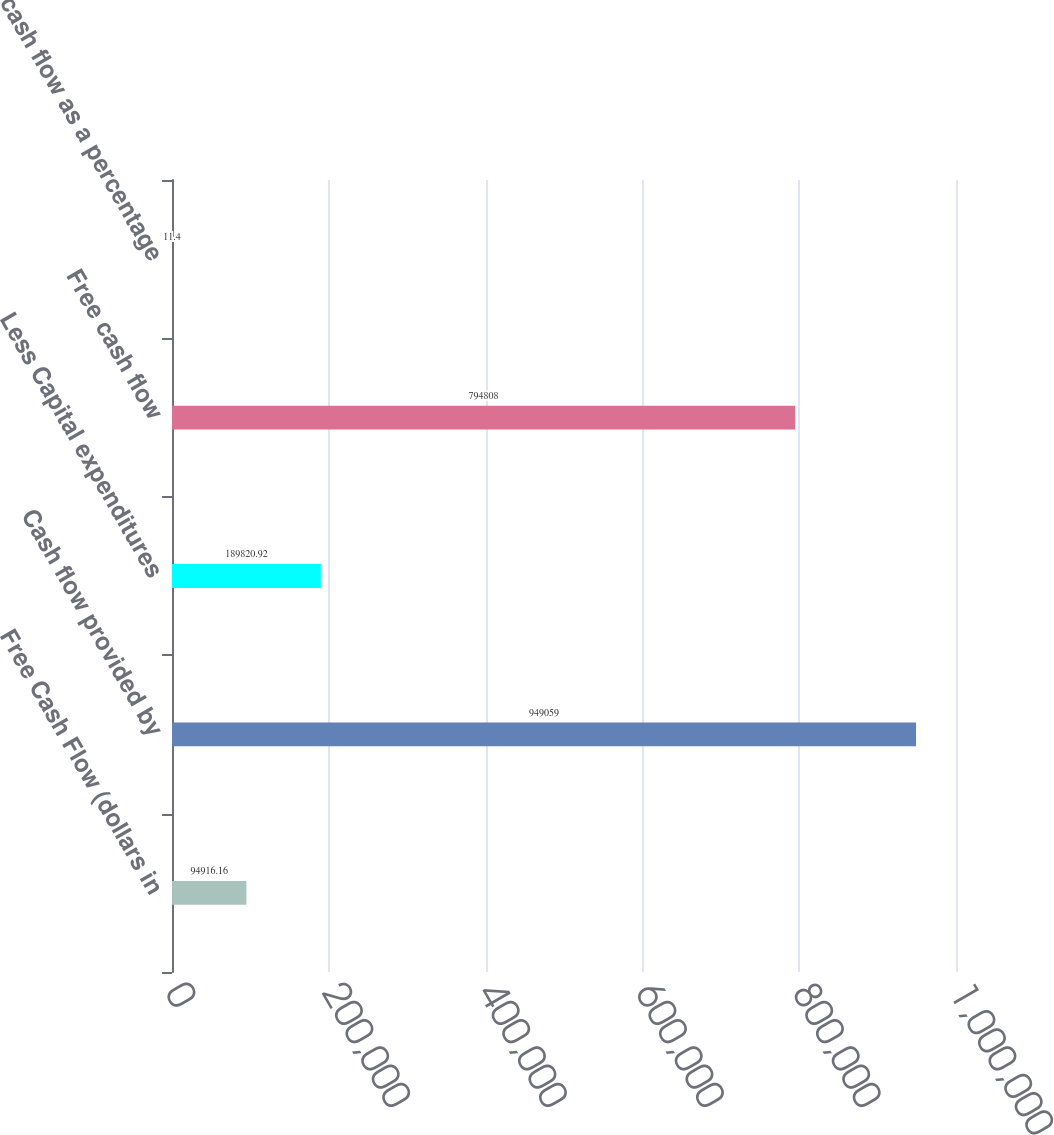Convert chart. <chart><loc_0><loc_0><loc_500><loc_500><bar_chart><fcel>Free Cash Flow (dollars in<fcel>Cash flow provided by<fcel>Less Capital expenditures<fcel>Free cash flow<fcel>Free cash flow as a percentage<nl><fcel>94916.2<fcel>949059<fcel>189821<fcel>794808<fcel>11.4<nl></chart> 